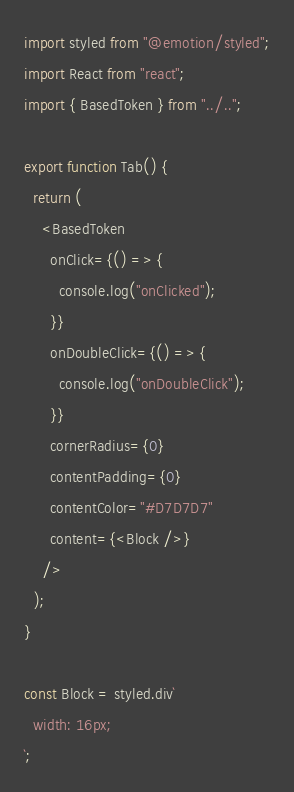Convert code to text. <code><loc_0><loc_0><loc_500><loc_500><_TypeScript_>import styled from "@emotion/styled";
import React from "react";
import { BasedToken } from "../..";

export function Tab() {
  return (
    <BasedToken
      onClick={() => {
        console.log("onClicked");
      }}
      onDoubleClick={() => {
        console.log("onDoubleClick");
      }}
      cornerRadius={0}
      contentPadding={0}
      contentColor="#D7D7D7"
      content={<Block />}
    />
  );
}

const Block = styled.div`
  width: 16px;
`;
</code> 